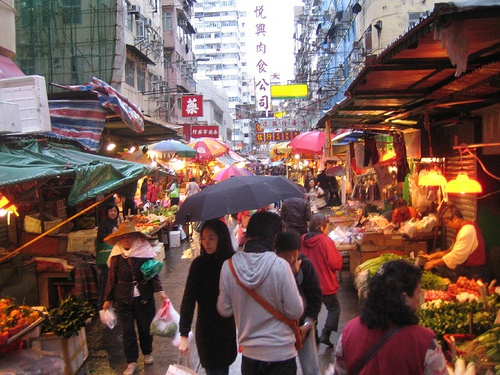Describe the objects in this image and their specific colors. I can see people in gray, black, and darkgray tones, people in gray, black, maroon, and brown tones, people in gray, black, maroon, and brown tones, people in gray, black, maroon, brown, and salmon tones, and umbrella in gray, purple, and black tones in this image. 